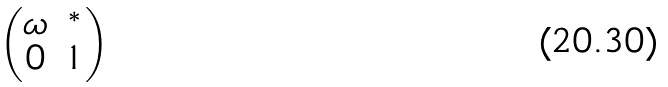<formula> <loc_0><loc_0><loc_500><loc_500>\begin{pmatrix} \omega & ^ { * } \\ 0 & 1 \end{pmatrix}</formula> 